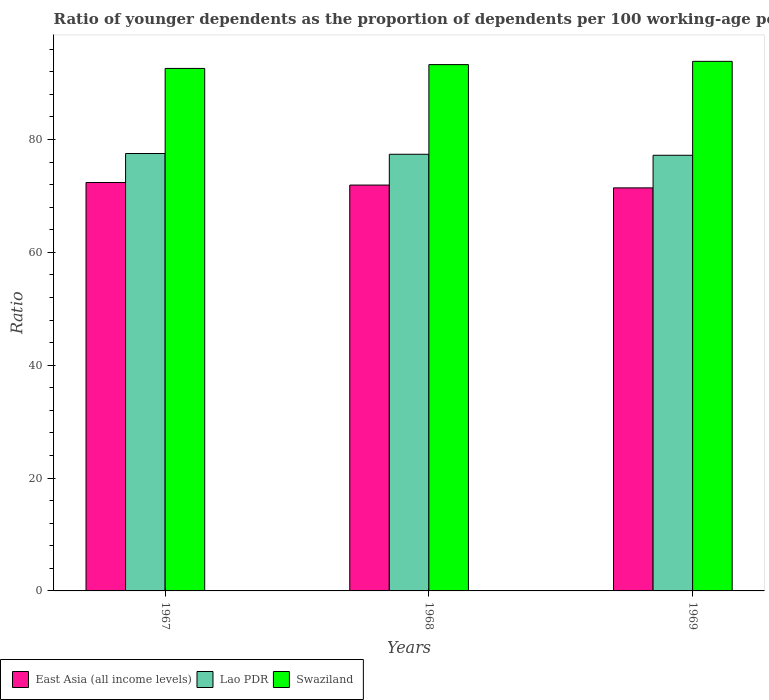Are the number of bars per tick equal to the number of legend labels?
Make the answer very short. Yes. What is the label of the 3rd group of bars from the left?
Offer a very short reply. 1969. What is the age dependency ratio(young) in East Asia (all income levels) in 1968?
Ensure brevity in your answer.  71.92. Across all years, what is the maximum age dependency ratio(young) in Swaziland?
Provide a succinct answer. 93.85. Across all years, what is the minimum age dependency ratio(young) in Swaziland?
Give a very brief answer. 92.59. In which year was the age dependency ratio(young) in East Asia (all income levels) maximum?
Your answer should be very brief. 1967. In which year was the age dependency ratio(young) in East Asia (all income levels) minimum?
Keep it short and to the point. 1969. What is the total age dependency ratio(young) in Swaziland in the graph?
Offer a very short reply. 279.71. What is the difference between the age dependency ratio(young) in Lao PDR in 1968 and that in 1969?
Provide a succinct answer. 0.18. What is the difference between the age dependency ratio(young) in Swaziland in 1968 and the age dependency ratio(young) in East Asia (all income levels) in 1967?
Your answer should be very brief. 20.89. What is the average age dependency ratio(young) in Lao PDR per year?
Ensure brevity in your answer.  77.37. In the year 1967, what is the difference between the age dependency ratio(young) in East Asia (all income levels) and age dependency ratio(young) in Swaziland?
Keep it short and to the point. -20.22. What is the ratio of the age dependency ratio(young) in East Asia (all income levels) in 1967 to that in 1968?
Your answer should be compact. 1.01. What is the difference between the highest and the second highest age dependency ratio(young) in Swaziland?
Provide a succinct answer. 0.58. What is the difference between the highest and the lowest age dependency ratio(young) in East Asia (all income levels)?
Keep it short and to the point. 0.95. In how many years, is the age dependency ratio(young) in East Asia (all income levels) greater than the average age dependency ratio(young) in East Asia (all income levels) taken over all years?
Make the answer very short. 2. Is the sum of the age dependency ratio(young) in Swaziland in 1967 and 1969 greater than the maximum age dependency ratio(young) in East Asia (all income levels) across all years?
Keep it short and to the point. Yes. What does the 1st bar from the left in 1967 represents?
Provide a short and direct response. East Asia (all income levels). What does the 1st bar from the right in 1969 represents?
Give a very brief answer. Swaziland. Is it the case that in every year, the sum of the age dependency ratio(young) in Lao PDR and age dependency ratio(young) in East Asia (all income levels) is greater than the age dependency ratio(young) in Swaziland?
Offer a very short reply. Yes. How many bars are there?
Your response must be concise. 9. Are all the bars in the graph horizontal?
Your answer should be compact. No. How many years are there in the graph?
Offer a very short reply. 3. What is the difference between two consecutive major ticks on the Y-axis?
Offer a very short reply. 20. Does the graph contain grids?
Provide a succinct answer. No. Where does the legend appear in the graph?
Keep it short and to the point. Bottom left. How many legend labels are there?
Keep it short and to the point. 3. What is the title of the graph?
Ensure brevity in your answer.  Ratio of younger dependents as the proportion of dependents per 100 working-age population. Does "Iran" appear as one of the legend labels in the graph?
Your answer should be compact. No. What is the label or title of the X-axis?
Ensure brevity in your answer.  Years. What is the label or title of the Y-axis?
Offer a terse response. Ratio. What is the Ratio in East Asia (all income levels) in 1967?
Offer a very short reply. 72.38. What is the Ratio in Lao PDR in 1967?
Provide a short and direct response. 77.52. What is the Ratio of Swaziland in 1967?
Keep it short and to the point. 92.59. What is the Ratio in East Asia (all income levels) in 1968?
Keep it short and to the point. 71.92. What is the Ratio of Lao PDR in 1968?
Offer a very short reply. 77.38. What is the Ratio of Swaziland in 1968?
Keep it short and to the point. 93.27. What is the Ratio of East Asia (all income levels) in 1969?
Ensure brevity in your answer.  71.43. What is the Ratio in Lao PDR in 1969?
Your answer should be compact. 77.2. What is the Ratio in Swaziland in 1969?
Your answer should be very brief. 93.85. Across all years, what is the maximum Ratio of East Asia (all income levels)?
Offer a terse response. 72.38. Across all years, what is the maximum Ratio of Lao PDR?
Make the answer very short. 77.52. Across all years, what is the maximum Ratio in Swaziland?
Offer a very short reply. 93.85. Across all years, what is the minimum Ratio of East Asia (all income levels)?
Your response must be concise. 71.43. Across all years, what is the minimum Ratio of Lao PDR?
Your response must be concise. 77.2. Across all years, what is the minimum Ratio of Swaziland?
Offer a terse response. 92.59. What is the total Ratio in East Asia (all income levels) in the graph?
Ensure brevity in your answer.  215.73. What is the total Ratio in Lao PDR in the graph?
Your response must be concise. 232.1. What is the total Ratio in Swaziland in the graph?
Ensure brevity in your answer.  279.71. What is the difference between the Ratio in East Asia (all income levels) in 1967 and that in 1968?
Keep it short and to the point. 0.45. What is the difference between the Ratio in Lao PDR in 1967 and that in 1968?
Your answer should be compact. 0.14. What is the difference between the Ratio in Swaziland in 1967 and that in 1968?
Your answer should be very brief. -0.68. What is the difference between the Ratio of East Asia (all income levels) in 1967 and that in 1969?
Make the answer very short. 0.95. What is the difference between the Ratio in Lao PDR in 1967 and that in 1969?
Ensure brevity in your answer.  0.31. What is the difference between the Ratio of Swaziland in 1967 and that in 1969?
Offer a terse response. -1.25. What is the difference between the Ratio in East Asia (all income levels) in 1968 and that in 1969?
Provide a short and direct response. 0.5. What is the difference between the Ratio of Lao PDR in 1968 and that in 1969?
Make the answer very short. 0.18. What is the difference between the Ratio in Swaziland in 1968 and that in 1969?
Give a very brief answer. -0.58. What is the difference between the Ratio of East Asia (all income levels) in 1967 and the Ratio of Lao PDR in 1968?
Offer a terse response. -5. What is the difference between the Ratio in East Asia (all income levels) in 1967 and the Ratio in Swaziland in 1968?
Your response must be concise. -20.89. What is the difference between the Ratio of Lao PDR in 1967 and the Ratio of Swaziland in 1968?
Keep it short and to the point. -15.75. What is the difference between the Ratio of East Asia (all income levels) in 1967 and the Ratio of Lao PDR in 1969?
Make the answer very short. -4.83. What is the difference between the Ratio of East Asia (all income levels) in 1967 and the Ratio of Swaziland in 1969?
Offer a terse response. -21.47. What is the difference between the Ratio in Lao PDR in 1967 and the Ratio in Swaziland in 1969?
Your answer should be compact. -16.33. What is the difference between the Ratio of East Asia (all income levels) in 1968 and the Ratio of Lao PDR in 1969?
Offer a terse response. -5.28. What is the difference between the Ratio of East Asia (all income levels) in 1968 and the Ratio of Swaziland in 1969?
Your response must be concise. -21.92. What is the difference between the Ratio in Lao PDR in 1968 and the Ratio in Swaziland in 1969?
Offer a very short reply. -16.47. What is the average Ratio in East Asia (all income levels) per year?
Provide a short and direct response. 71.91. What is the average Ratio of Lao PDR per year?
Make the answer very short. 77.37. What is the average Ratio of Swaziland per year?
Provide a succinct answer. 93.24. In the year 1967, what is the difference between the Ratio in East Asia (all income levels) and Ratio in Lao PDR?
Provide a short and direct response. -5.14. In the year 1967, what is the difference between the Ratio of East Asia (all income levels) and Ratio of Swaziland?
Ensure brevity in your answer.  -20.22. In the year 1967, what is the difference between the Ratio of Lao PDR and Ratio of Swaziland?
Your answer should be compact. -15.08. In the year 1968, what is the difference between the Ratio of East Asia (all income levels) and Ratio of Lao PDR?
Offer a very short reply. -5.46. In the year 1968, what is the difference between the Ratio in East Asia (all income levels) and Ratio in Swaziland?
Provide a succinct answer. -21.35. In the year 1968, what is the difference between the Ratio of Lao PDR and Ratio of Swaziland?
Ensure brevity in your answer.  -15.89. In the year 1969, what is the difference between the Ratio in East Asia (all income levels) and Ratio in Lao PDR?
Ensure brevity in your answer.  -5.78. In the year 1969, what is the difference between the Ratio of East Asia (all income levels) and Ratio of Swaziland?
Make the answer very short. -22.42. In the year 1969, what is the difference between the Ratio of Lao PDR and Ratio of Swaziland?
Your response must be concise. -16.64. What is the ratio of the Ratio of Lao PDR in 1967 to that in 1968?
Your answer should be very brief. 1. What is the ratio of the Ratio in East Asia (all income levels) in 1967 to that in 1969?
Your answer should be compact. 1.01. What is the ratio of the Ratio of Lao PDR in 1967 to that in 1969?
Your answer should be very brief. 1. What is the ratio of the Ratio in Swaziland in 1967 to that in 1969?
Keep it short and to the point. 0.99. What is the ratio of the Ratio of Swaziland in 1968 to that in 1969?
Keep it short and to the point. 0.99. What is the difference between the highest and the second highest Ratio in East Asia (all income levels)?
Make the answer very short. 0.45. What is the difference between the highest and the second highest Ratio in Lao PDR?
Give a very brief answer. 0.14. What is the difference between the highest and the second highest Ratio in Swaziland?
Ensure brevity in your answer.  0.58. What is the difference between the highest and the lowest Ratio of East Asia (all income levels)?
Keep it short and to the point. 0.95. What is the difference between the highest and the lowest Ratio of Lao PDR?
Your answer should be compact. 0.31. What is the difference between the highest and the lowest Ratio in Swaziland?
Offer a terse response. 1.25. 